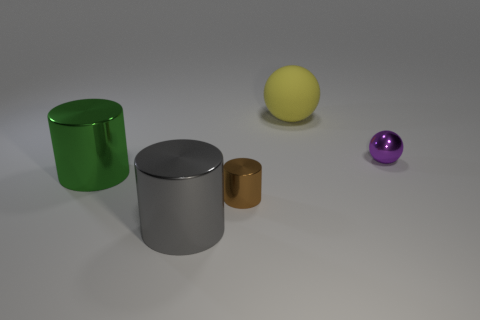Add 2 green things. How many objects exist? 7 Subtract all big cylinders. How many cylinders are left? 1 Subtract all cylinders. How many objects are left? 2 Subtract all yellow matte spheres. Subtract all large metal cylinders. How many objects are left? 2 Add 4 small shiny objects. How many small shiny objects are left? 6 Add 3 large gray matte spheres. How many large gray matte spheres exist? 3 Subtract 0 purple blocks. How many objects are left? 5 